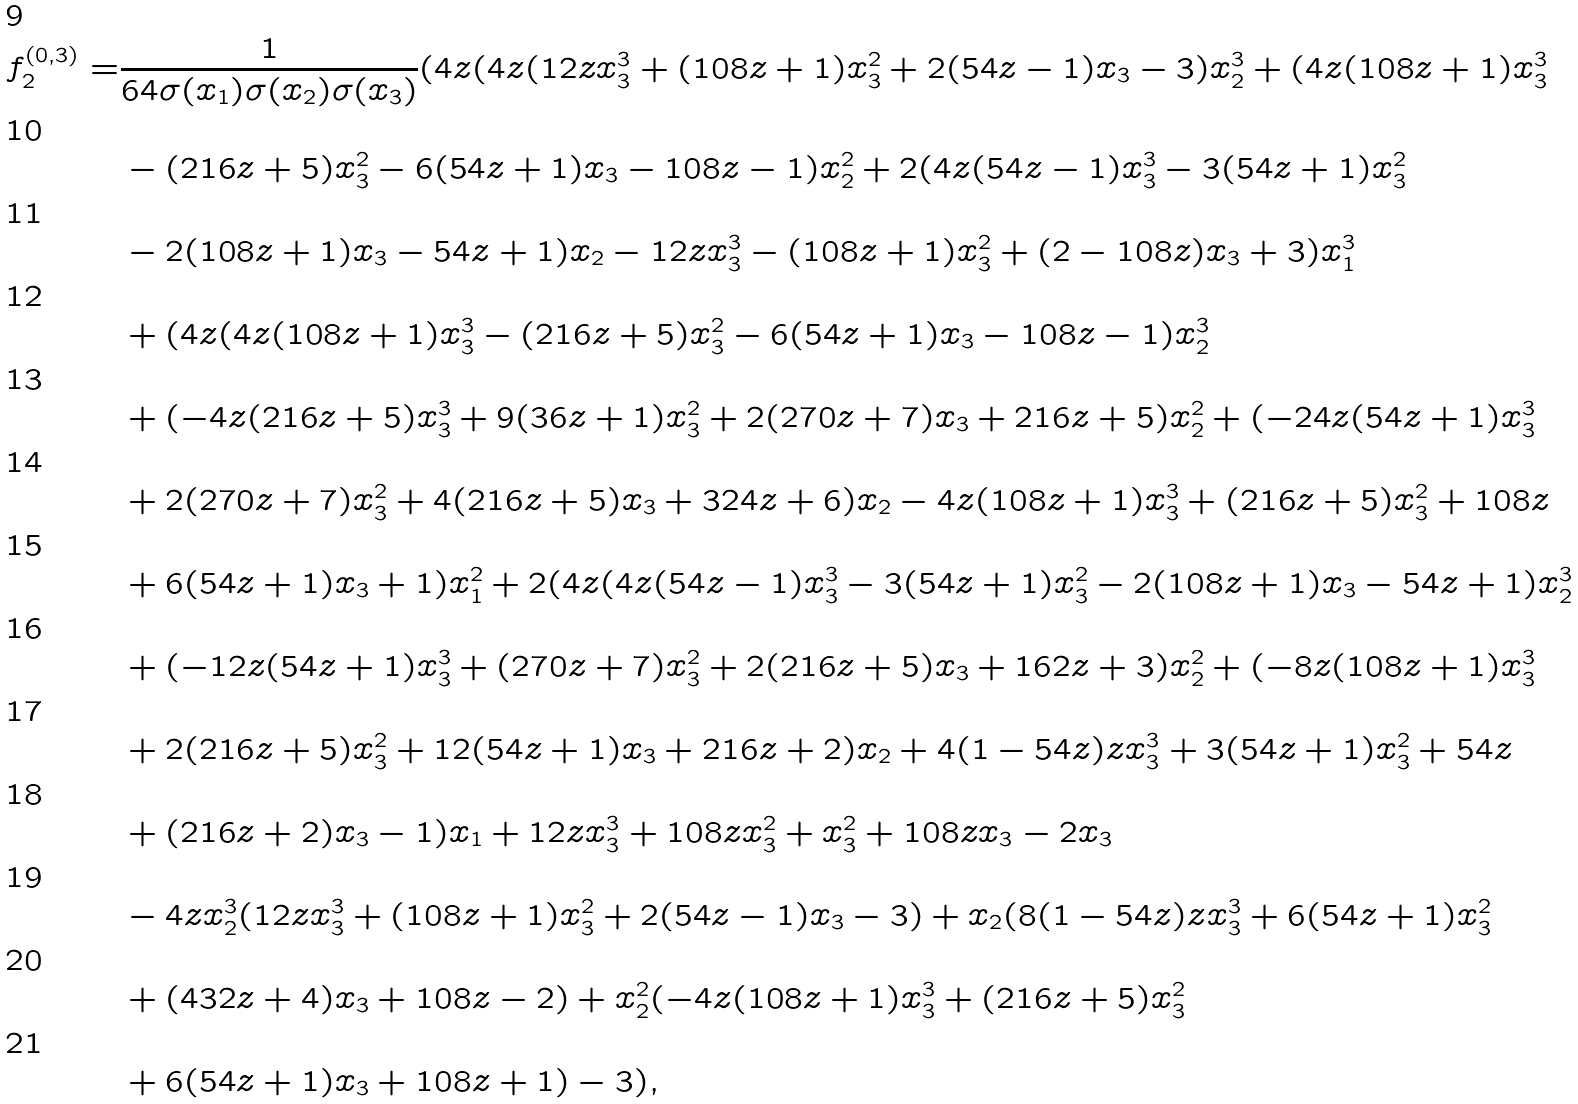Convert formula to latex. <formula><loc_0><loc_0><loc_500><loc_500>f _ { 2 } ^ { ( 0 , 3 ) } = & \frac { 1 } { 6 4 \sigma ( x _ { 1 } ) \sigma ( x _ { 2 } ) \sigma ( x _ { 3 } ) } ( 4 z ( 4 z ( 1 2 z x _ { 3 } ^ { 3 } + ( 1 0 8 z + 1 ) x _ { 3 } ^ { 2 } + 2 ( 5 4 z - 1 ) x _ { 3 } - 3 ) x _ { 2 } ^ { 3 } + ( 4 z ( 1 0 8 z + 1 ) x _ { 3 } ^ { 3 } \\ & - ( 2 1 6 z + 5 ) x _ { 3 } ^ { 2 } - 6 ( 5 4 z + 1 ) x _ { 3 } - 1 0 8 z - 1 ) x _ { 2 } ^ { 2 } + 2 ( 4 z ( 5 4 z - 1 ) x _ { 3 } ^ { 3 } - 3 ( 5 4 z + 1 ) x _ { 3 } ^ { 2 } \\ & - 2 ( 1 0 8 z + 1 ) x _ { 3 } - 5 4 z + 1 ) x _ { 2 } - 1 2 z x _ { 3 } ^ { 3 } - ( 1 0 8 z + 1 ) x _ { 3 } ^ { 2 } + ( 2 - 1 0 8 z ) x _ { 3 } + 3 ) x _ { 1 } ^ { 3 } \\ & + ( 4 z ( 4 z ( 1 0 8 z + 1 ) x _ { 3 } ^ { 3 } - ( 2 1 6 z + 5 ) x _ { 3 } ^ { 2 } - 6 ( 5 4 z + 1 ) x _ { 3 } - 1 0 8 z - 1 ) x _ { 2 } ^ { 3 } \\ & + ( - 4 z ( 2 1 6 z + 5 ) x _ { 3 } ^ { 3 } + 9 ( 3 6 z + 1 ) x _ { 3 } ^ { 2 } + 2 ( 2 7 0 z + 7 ) x _ { 3 } + 2 1 6 z + 5 ) x _ { 2 } ^ { 2 } + ( - 2 4 z ( 5 4 z + 1 ) x _ { 3 } ^ { 3 } \\ & + 2 ( 2 7 0 z + 7 ) x _ { 3 } ^ { 2 } + 4 ( 2 1 6 z + 5 ) x _ { 3 } + 3 2 4 z + 6 ) x _ { 2 } - 4 z ( 1 0 8 z + 1 ) x _ { 3 } ^ { 3 } + ( 2 1 6 z + 5 ) x _ { 3 } ^ { 2 } + 1 0 8 z \\ & + 6 ( 5 4 z + 1 ) x _ { 3 } + 1 ) x _ { 1 } ^ { 2 } + 2 ( 4 z ( 4 z ( 5 4 z - 1 ) x _ { 3 } ^ { 3 } - 3 ( 5 4 z + 1 ) x _ { 3 } ^ { 2 } - 2 ( 1 0 8 z + 1 ) x _ { 3 } - 5 4 z + 1 ) x _ { 2 } ^ { 3 } \\ & + ( - 1 2 z ( 5 4 z + 1 ) x _ { 3 } ^ { 3 } + ( 2 7 0 z + 7 ) x _ { 3 } ^ { 2 } + 2 ( 2 1 6 z + 5 ) x _ { 3 } + 1 6 2 z + 3 ) x _ { 2 } ^ { 2 } + ( - 8 z ( 1 0 8 z + 1 ) x _ { 3 } ^ { 3 } \\ & + 2 ( 2 1 6 z + 5 ) x _ { 3 } ^ { 2 } + 1 2 ( 5 4 z + 1 ) x _ { 3 } + 2 1 6 z + 2 ) x _ { 2 } + 4 ( 1 - 5 4 z ) z x _ { 3 } ^ { 3 } + 3 ( 5 4 z + 1 ) x _ { 3 } ^ { 2 } + 5 4 z \\ & + ( 2 1 6 z + 2 ) x _ { 3 } - 1 ) x _ { 1 } + 1 2 z x _ { 3 } ^ { 3 } + 1 0 8 z x _ { 3 } ^ { 2 } + x _ { 3 } ^ { 2 } + 1 0 8 z x _ { 3 } - 2 x _ { 3 } \\ & - 4 z x _ { 2 } ^ { 3 } ( 1 2 z x _ { 3 } ^ { 3 } + ( 1 0 8 z + 1 ) x _ { 3 } ^ { 2 } + 2 ( 5 4 z - 1 ) x _ { 3 } - 3 ) + x _ { 2 } ( 8 ( 1 - 5 4 z ) z x _ { 3 } ^ { 3 } + 6 ( 5 4 z + 1 ) x _ { 3 } ^ { 2 } \\ & + ( 4 3 2 z + 4 ) x _ { 3 } + 1 0 8 z - 2 ) + x _ { 2 } ^ { 2 } ( - 4 z ( 1 0 8 z + 1 ) x _ { 3 } ^ { 3 } + ( 2 1 6 z + 5 ) x _ { 3 } ^ { 2 } \\ & + 6 ( 5 4 z + 1 ) x _ { 3 } + 1 0 8 z + 1 ) - 3 ) ,</formula> 